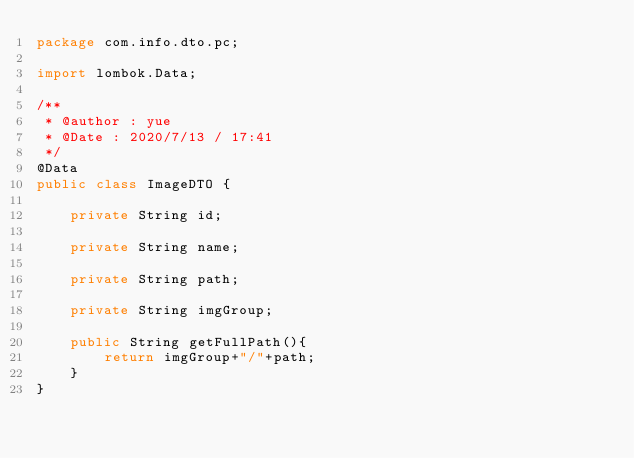Convert code to text. <code><loc_0><loc_0><loc_500><loc_500><_Java_>package com.info.dto.pc;

import lombok.Data;

/**
 * @author : yue
 * @Date : 2020/7/13 / 17:41
 */
@Data
public class ImageDTO {

    private String id;

    private String name;

    private String path;

    private String imgGroup;

    public String getFullPath(){
        return imgGroup+"/"+path;
    }
}
</code> 